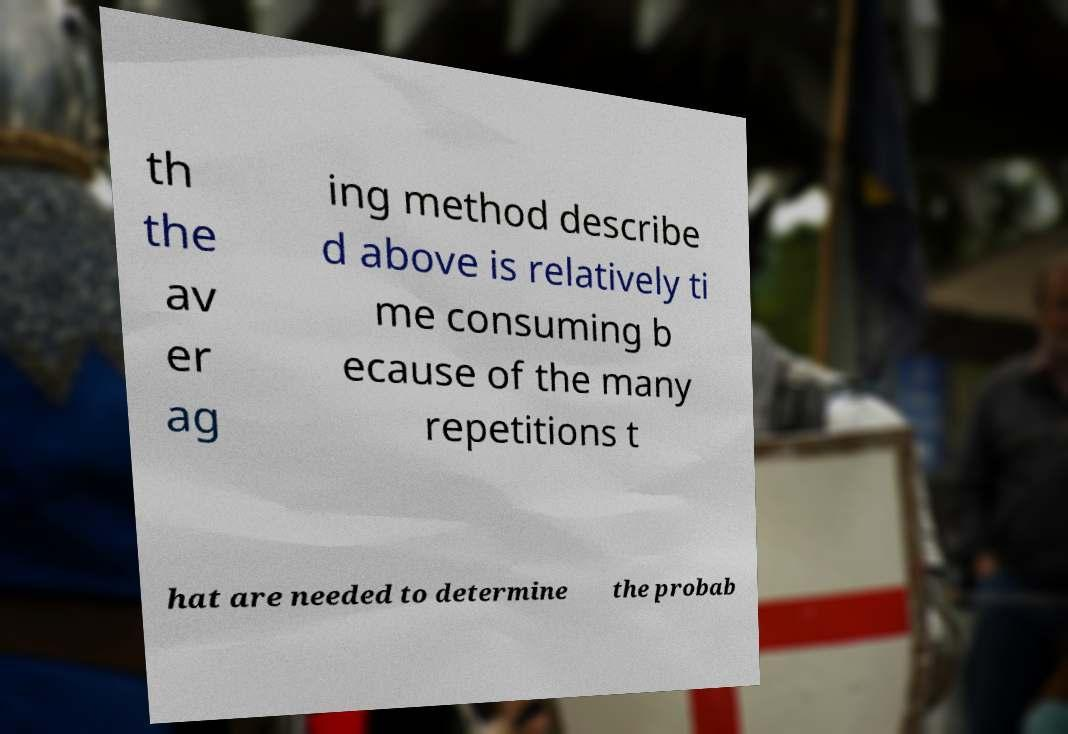For documentation purposes, I need the text within this image transcribed. Could you provide that? th the av er ag ing method describe d above is relatively ti me consuming b ecause of the many repetitions t hat are needed to determine the probab 